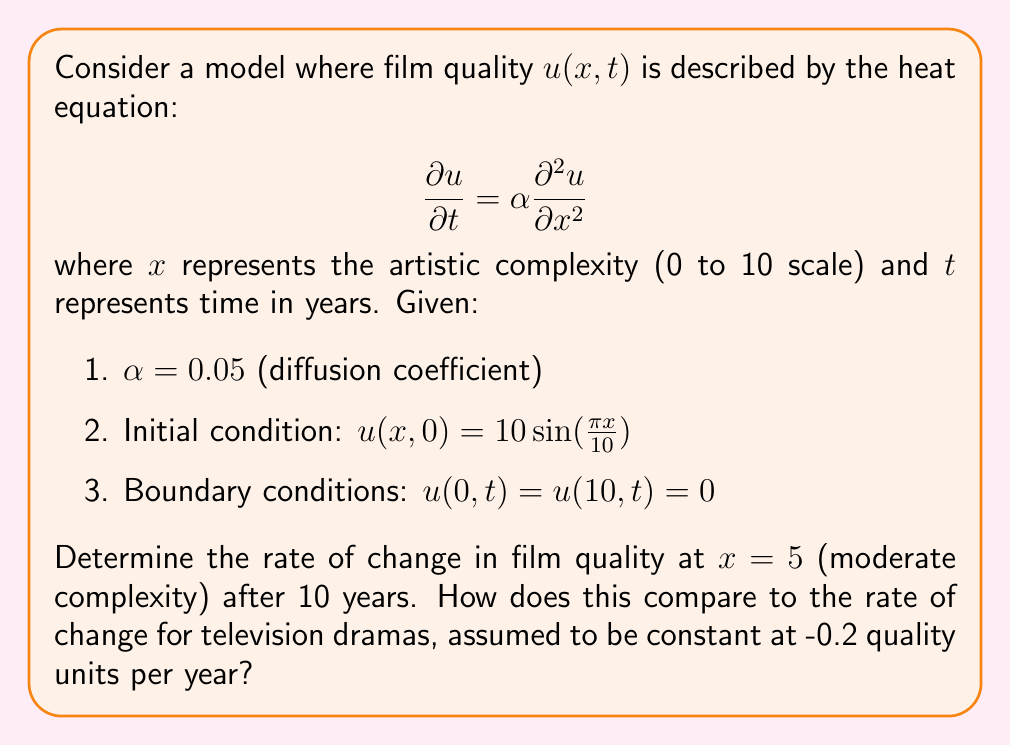What is the answer to this math problem? To solve this problem, we need to use the separation of variables method for the heat equation.

1) Assume a solution of the form $u(x,t) = X(x)T(t)$

2) Substituting into the heat equation:

   $$X(x)T'(t) = \alpha X''(x)T(t)$$

3) Separating variables:

   $$\frac{T'(t)}{T(t)} = \alpha \frac{X''(x)}{X(x)} = -\lambda$$

4) Solving for $X(x)$:

   $$X'' + \lambda X = 0$$
   
   With boundary conditions, we get $X_n(x) = \sin(\frac{n\pi x}{10})$ and $\lambda_n = (\frac{n\pi}{10})^2$

5) Solving for $T(t)$:

   $$T_n(t) = e^{-\alpha \lambda_n t} = e^{-\alpha (\frac{n\pi}{10})^2 t}$$

6) The general solution is:

   $$u(x,t) = \sum_{n=1}^{\infty} A_n \sin(\frac{n\pi x}{10}) e^{-\alpha (\frac{n\pi}{10})^2 t}$$

7) From the initial condition, we see that only $n=1$ term is non-zero, with $A_1 = 10$

8) Therefore, the solution is:

   $$u(x,t) = 10 \sin(\frac{\pi x}{10}) e^{-\alpha (\frac{\pi}{10})^2 t}$$

9) To find the rate of change, we differentiate with respect to t:

   $$\frac{\partial u}{\partial t} = -10 \alpha (\frac{\pi}{10})^2 \sin(\frac{\pi x}{10}) e^{-\alpha (\frac{\pi}{10})^2 t}$$

10) At $x=5$ and $t=10$, with $\alpha = 0.05$:

    $$\frac{\partial u}{\partial t}(5,10) = -10 \cdot 0.05 \cdot (\frac{\pi}{10})^2 \cdot \sin(\frac{\pi}{2}) \cdot e^{-0.05 \cdot (\frac{\pi}{10})^2 \cdot 10}$$

11) Calculate this value and compare with -0.2 for television dramas.
Answer: $$\frac{\partial u}{\partial t}(5,10) \approx -0.1478$$

The rate of change in film quality at $x=5$ after 10 years is approximately -0.1478 quality units per year. This is less negative than the constant rate of -0.2 for television dramas, suggesting that film quality is decreasing more slowly than television drama quality, aligning with the persona's belief that cinema is a higher form of art. 